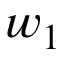<formula> <loc_0><loc_0><loc_500><loc_500>w _ { 1 }</formula> 